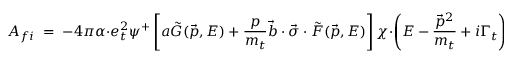Convert formula to latex. <formula><loc_0><loc_0><loc_500><loc_500>A _ { f i } \, = \, - 4 \pi \alpha \cdot e _ { t } ^ { 2 } \psi ^ { + } \left [ a \tilde { G } ( \vec { p } , E ) + \frac { p } { m _ { t } } \vec { b } \cdot \vec { \sigma } \cdot \tilde { F } ( \vec { p } , E ) \right ] \chi \cdot \left ( E - \frac { \vec { p } ^ { 2 } } { m _ { t } } + i \Gamma _ { t } \right ) .</formula> 